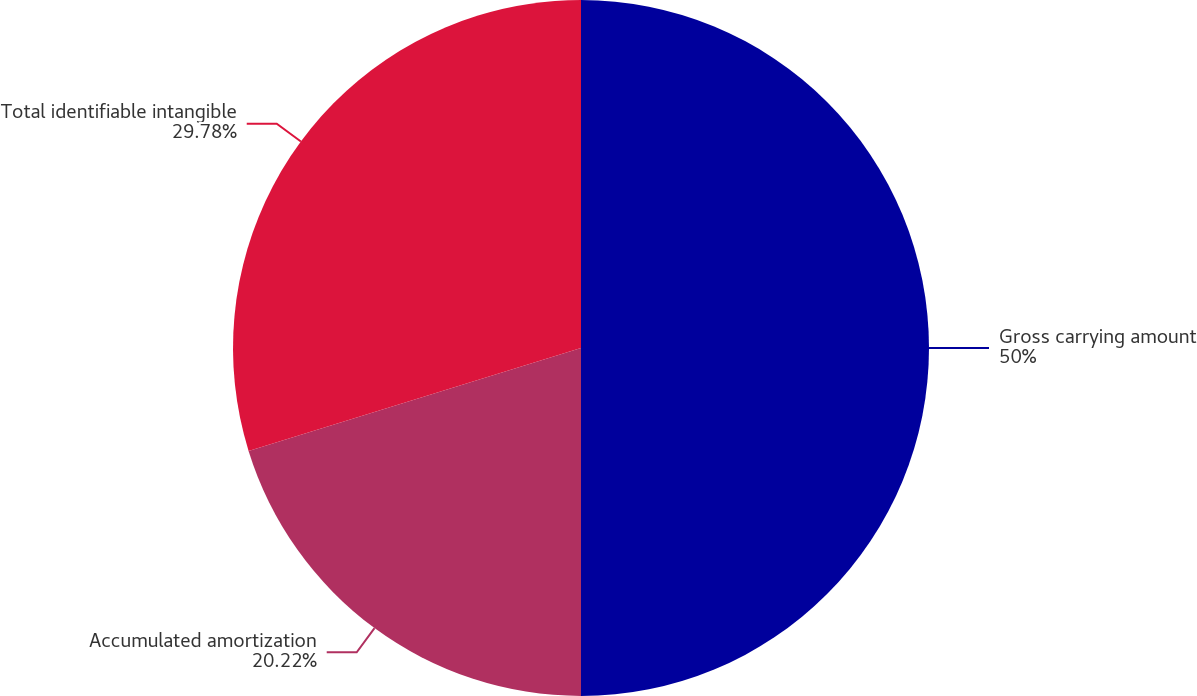Convert chart. <chart><loc_0><loc_0><loc_500><loc_500><pie_chart><fcel>Gross carrying amount<fcel>Accumulated amortization<fcel>Total identifiable intangible<nl><fcel>50.0%<fcel>20.22%<fcel>29.78%<nl></chart> 